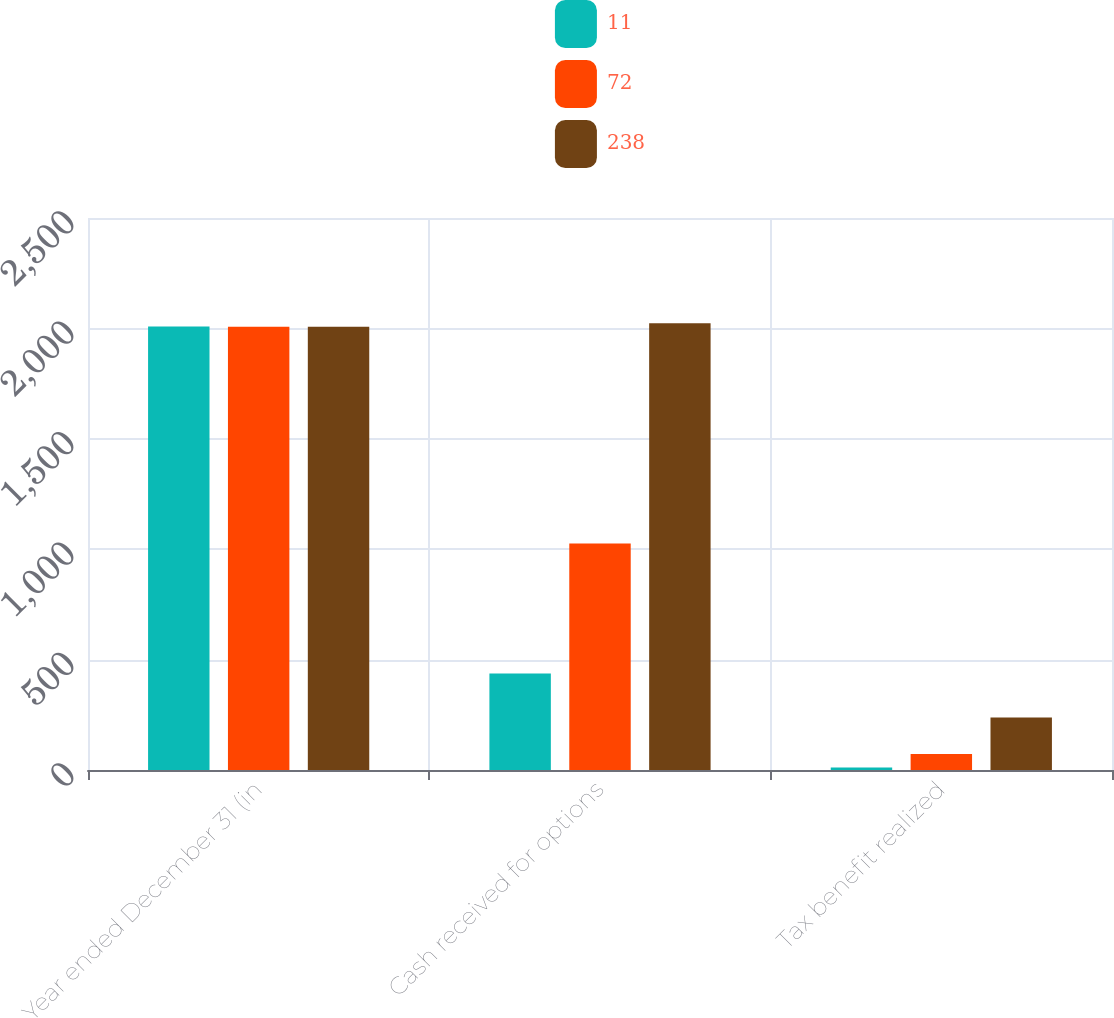<chart> <loc_0><loc_0><loc_500><loc_500><stacked_bar_chart><ecel><fcel>Year ended December 31 (in<fcel>Cash received for options<fcel>Tax benefit realized<nl><fcel>11<fcel>2009<fcel>437<fcel>11<nl><fcel>72<fcel>2008<fcel>1026<fcel>72<nl><fcel>238<fcel>2007<fcel>2023<fcel>238<nl></chart> 